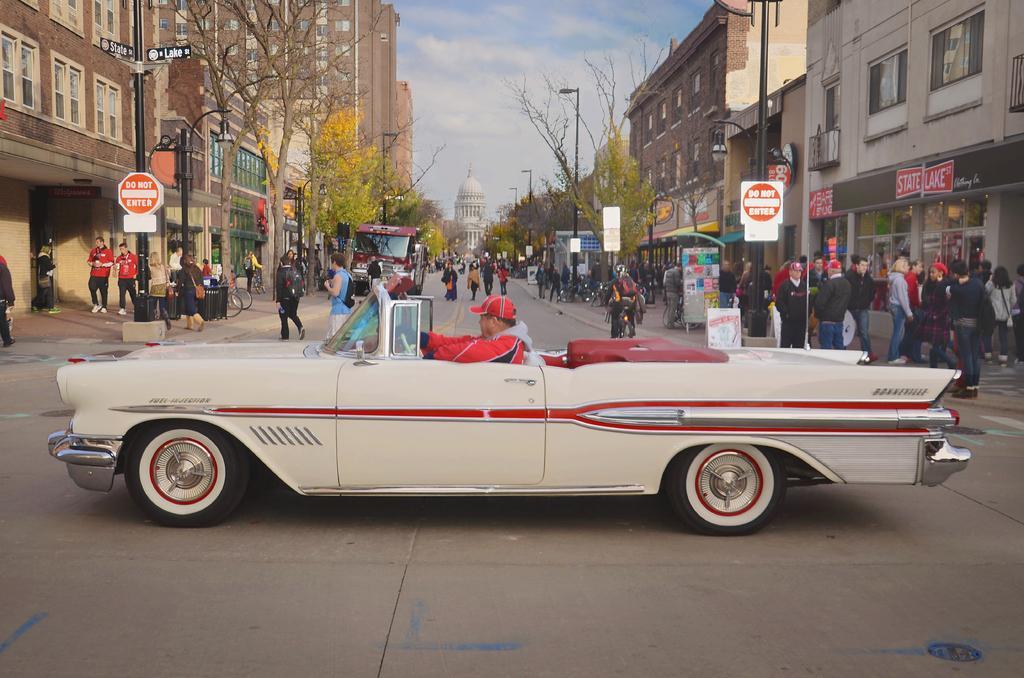Can you describe this image briefly? In this image we can see few people and vehicles on the road, a person driving a car and a person riding a bicycle, few boards to the pole, few people standing on the pavement and there are few buildings, trees, street lights and the sky on the top. 